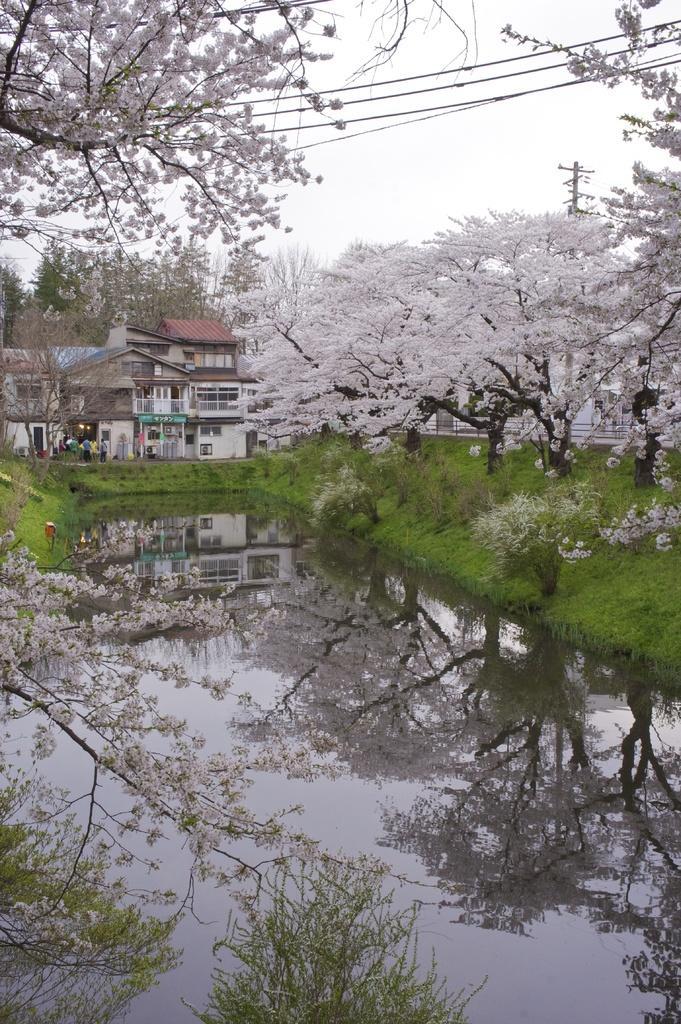Could you give a brief overview of what you see in this image? In the image I can see a lake and also I can see a building and some trees and plants. 